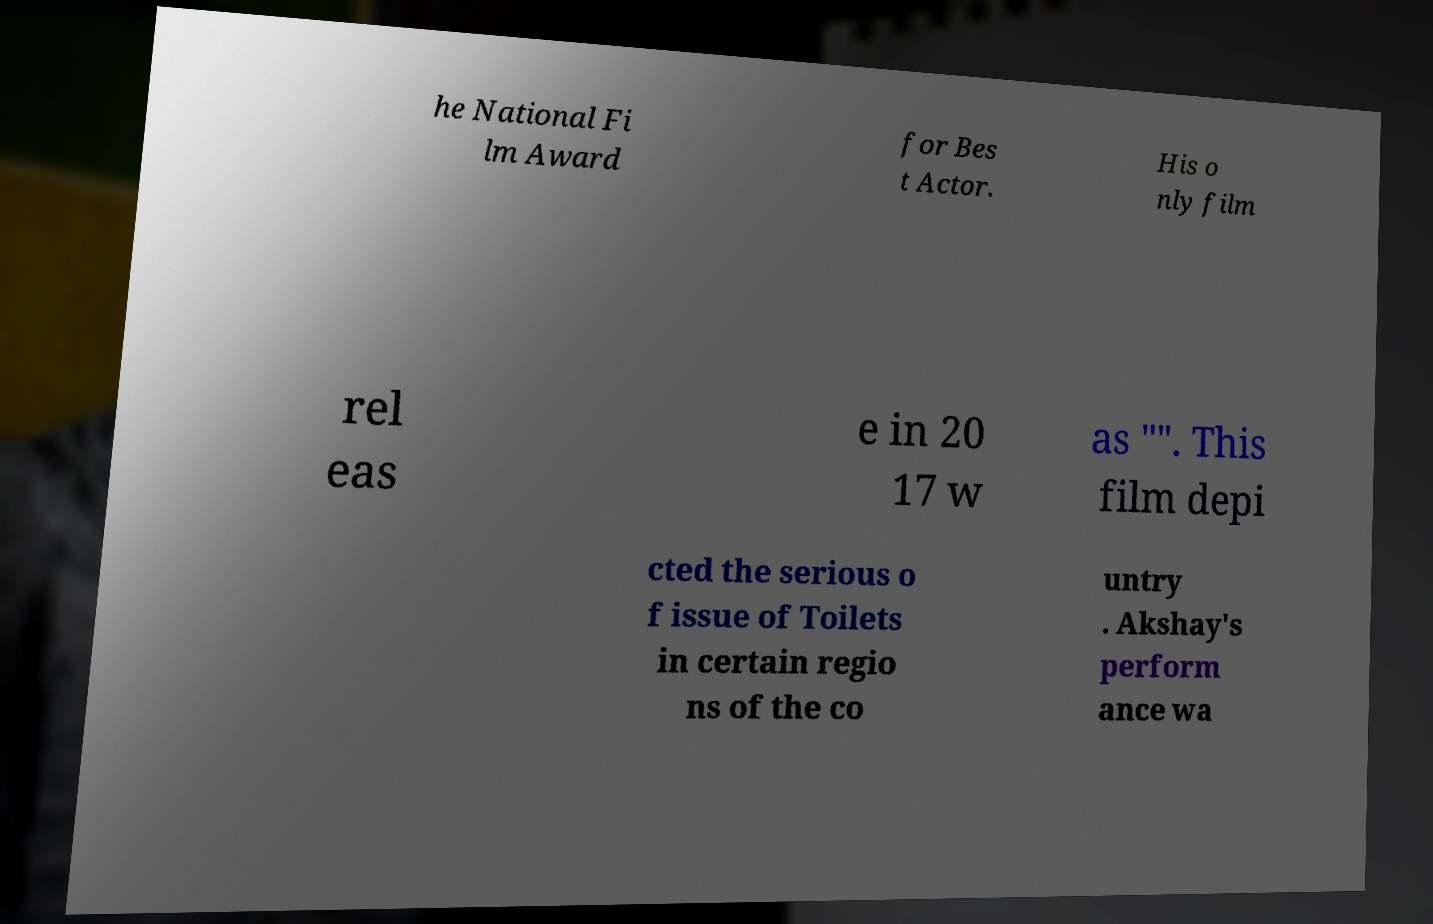I need the written content from this picture converted into text. Can you do that? he National Fi lm Award for Bes t Actor. His o nly film rel eas e in 20 17 w as "". This film depi cted the serious o f issue of Toilets in certain regio ns of the co untry . Akshay's perform ance wa 